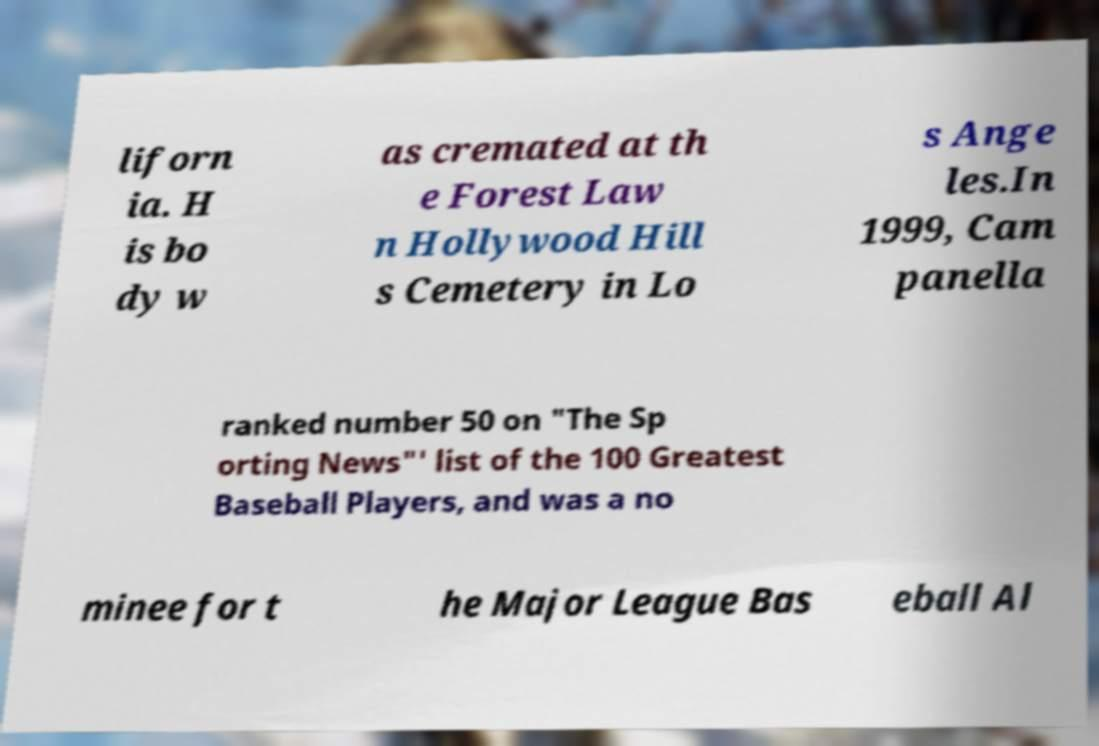Could you assist in decoding the text presented in this image and type it out clearly? liforn ia. H is bo dy w as cremated at th e Forest Law n Hollywood Hill s Cemetery in Lo s Ange les.In 1999, Cam panella ranked number 50 on "The Sp orting News"' list of the 100 Greatest Baseball Players, and was a no minee for t he Major League Bas eball Al 